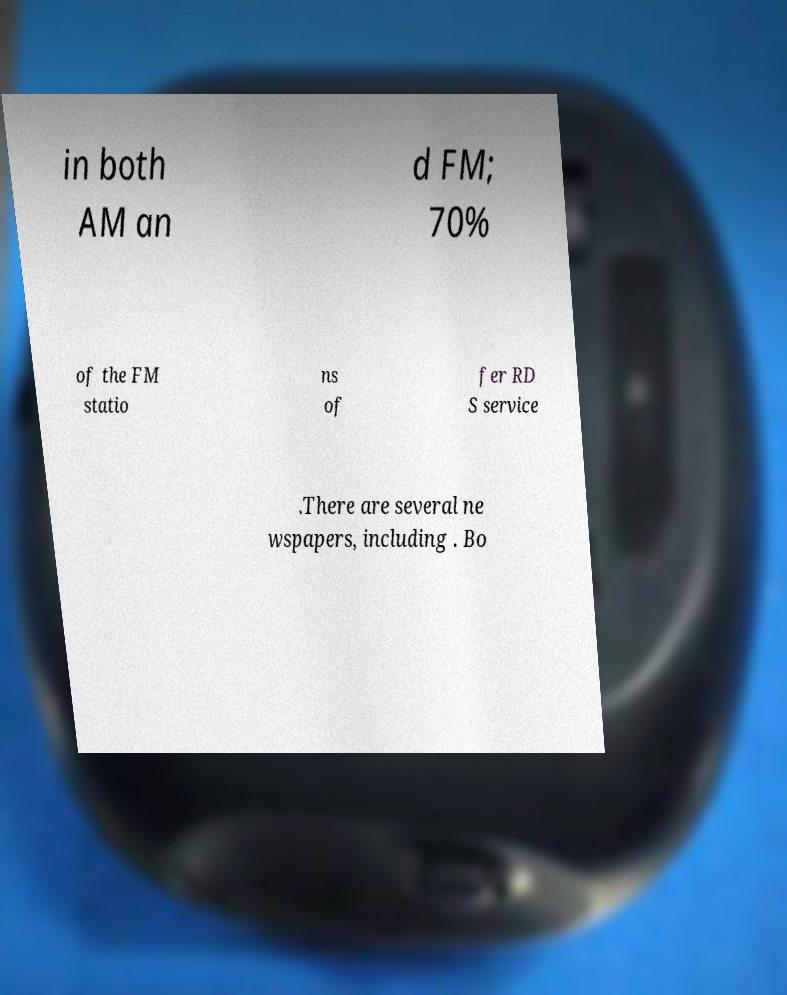Please identify and transcribe the text found in this image. in both AM an d FM; 70% of the FM statio ns of fer RD S service .There are several ne wspapers, including . Bo 